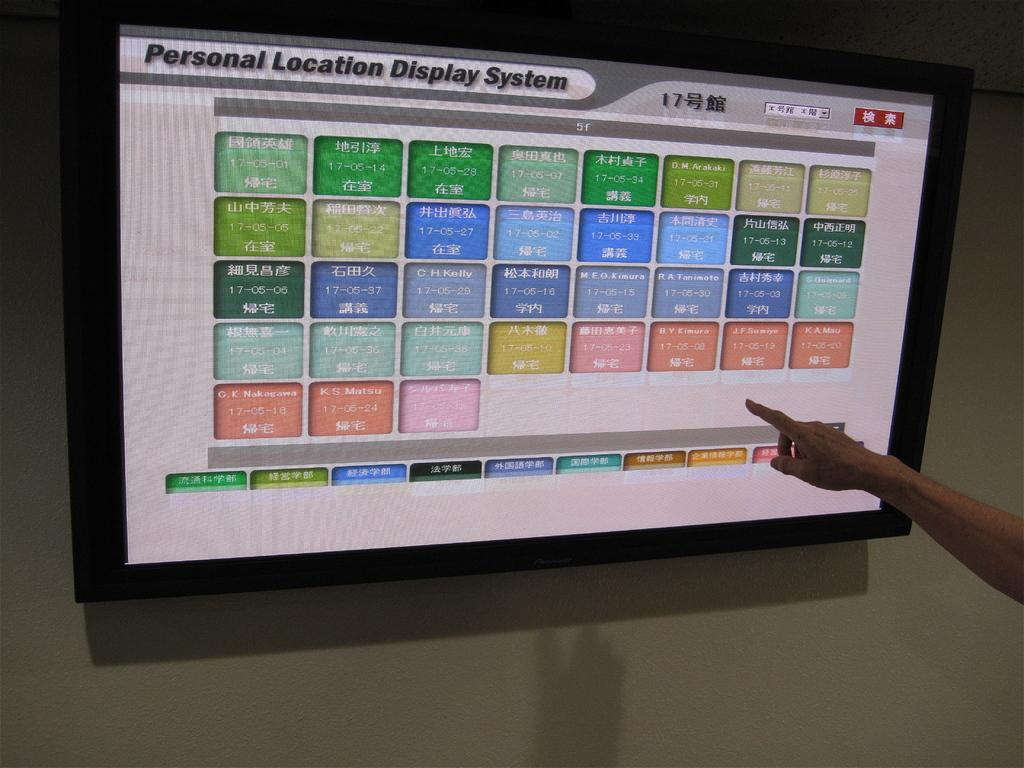<image>
Write a terse but informative summary of the picture. a monitor reading Personal Location Display System and a hand pointing at it 